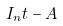Convert formula to latex. <formula><loc_0><loc_0><loc_500><loc_500>I _ { n } t - A</formula> 